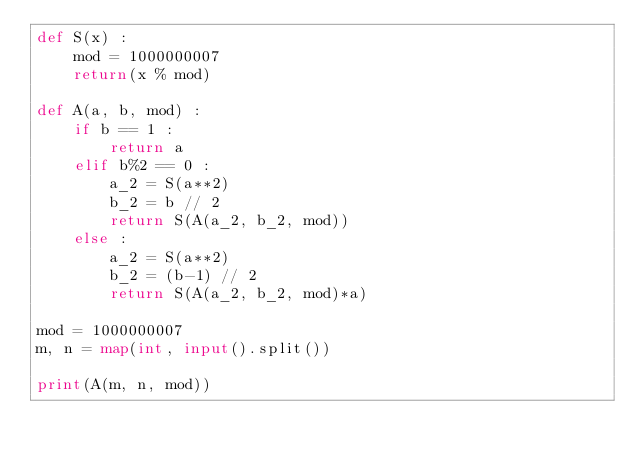<code> <loc_0><loc_0><loc_500><loc_500><_Python_>def S(x) :
    mod = 1000000007
    return(x % mod)
    
def A(a, b, mod) :
    if b == 1 :
        return a
    elif b%2 == 0 :
        a_2 = S(a**2)
        b_2 = b // 2
        return S(A(a_2, b_2, mod))
    else :
        a_2 = S(a**2)
        b_2 = (b-1) // 2
        return S(A(a_2, b_2, mod)*a)
        
mod = 1000000007
m, n = map(int, input().split())

print(A(m, n, mod))
</code> 